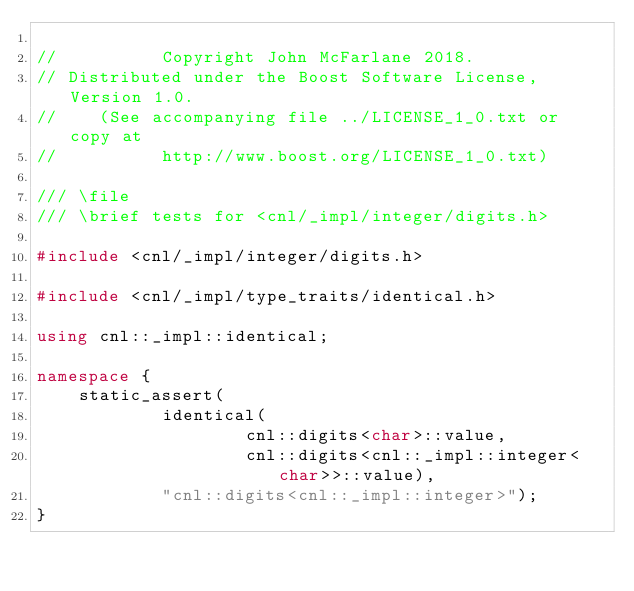<code> <loc_0><loc_0><loc_500><loc_500><_C++_>
//          Copyright John McFarlane 2018.
// Distributed under the Boost Software License, Version 1.0.
//    (See accompanying file ../LICENSE_1_0.txt or copy at
//          http://www.boost.org/LICENSE_1_0.txt)

/// \file
/// \brief tests for <cnl/_impl/integer/digits.h>

#include <cnl/_impl/integer/digits.h>

#include <cnl/_impl/type_traits/identical.h>

using cnl::_impl::identical;

namespace {
    static_assert(
            identical(
                    cnl::digits<char>::value,
                    cnl::digits<cnl::_impl::integer<char>>::value),
            "cnl::digits<cnl::_impl::integer>");
}
</code> 